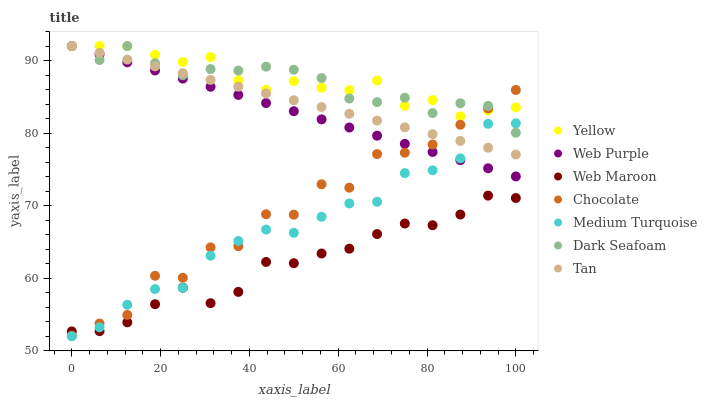Does Web Maroon have the minimum area under the curve?
Answer yes or no. Yes. Does Yellow have the maximum area under the curve?
Answer yes or no. Yes. Does Web Purple have the minimum area under the curve?
Answer yes or no. No. Does Web Purple have the maximum area under the curve?
Answer yes or no. No. Is Web Purple the smoothest?
Answer yes or no. Yes. Is Chocolate the roughest?
Answer yes or no. Yes. Is Yellow the smoothest?
Answer yes or no. No. Is Yellow the roughest?
Answer yes or no. No. Does Medium Turquoise have the lowest value?
Answer yes or no. Yes. Does Web Purple have the lowest value?
Answer yes or no. No. Does Tan have the highest value?
Answer yes or no. Yes. Does Chocolate have the highest value?
Answer yes or no. No. Is Web Maroon less than Dark Seafoam?
Answer yes or no. Yes. Is Web Purple greater than Web Maroon?
Answer yes or no. Yes. Does Chocolate intersect Tan?
Answer yes or no. Yes. Is Chocolate less than Tan?
Answer yes or no. No. Is Chocolate greater than Tan?
Answer yes or no. No. Does Web Maroon intersect Dark Seafoam?
Answer yes or no. No. 